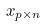Convert formula to latex. <formula><loc_0><loc_0><loc_500><loc_500>x _ { p \times n }</formula> 